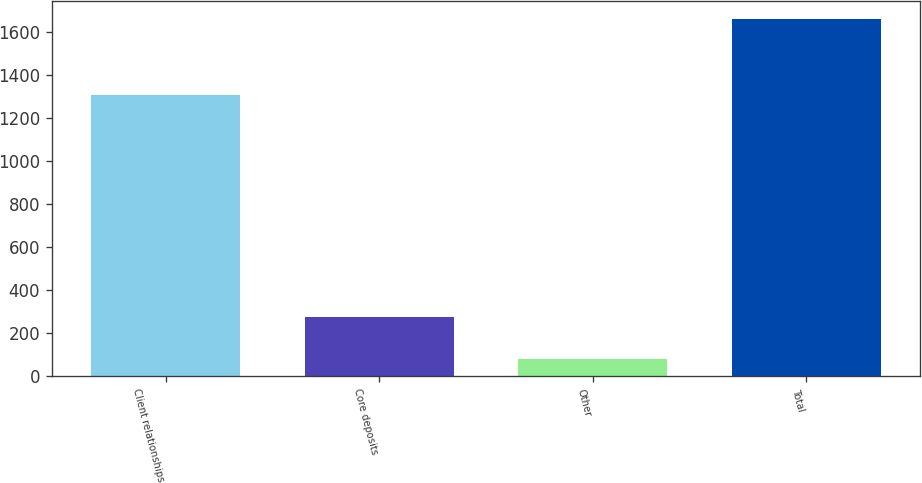Convert chart. <chart><loc_0><loc_0><loc_500><loc_500><bar_chart><fcel>Client relationships<fcel>Core deposits<fcel>Other<fcel>Total<nl><fcel>1306<fcel>277<fcel>80<fcel>1663<nl></chart> 